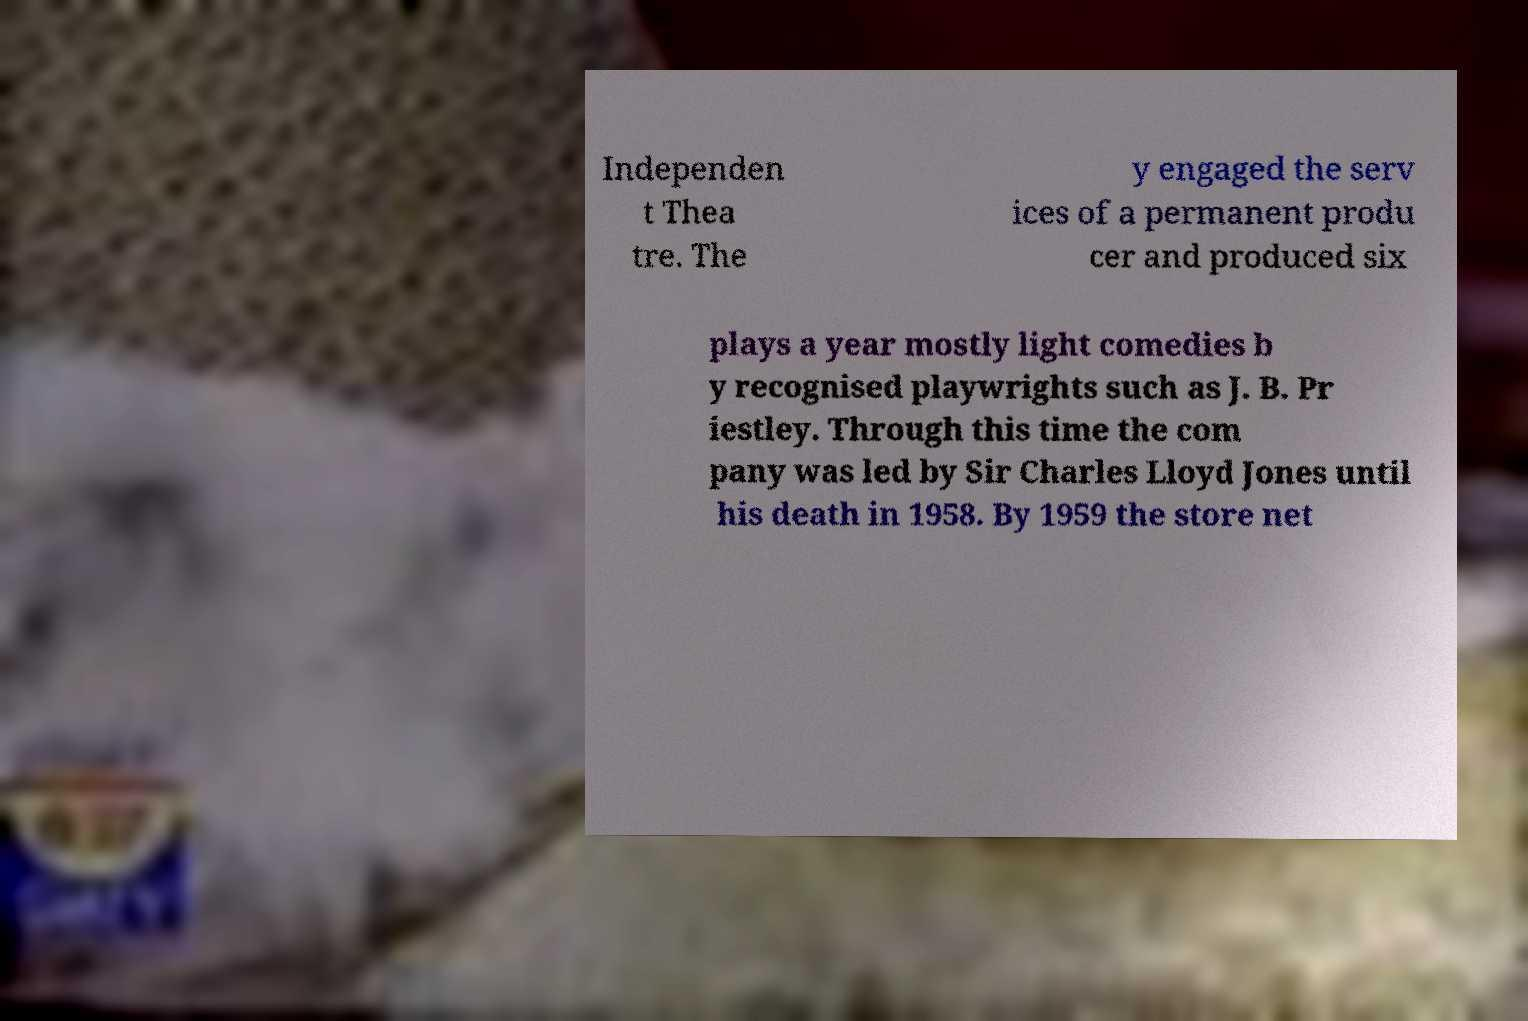Can you read and provide the text displayed in the image?This photo seems to have some interesting text. Can you extract and type it out for me? Independen t Thea tre. The y engaged the serv ices of a permanent produ cer and produced six plays a year mostly light comedies b y recognised playwrights such as J. B. Pr iestley. Through this time the com pany was led by Sir Charles Lloyd Jones until his death in 1958. By 1959 the store net 